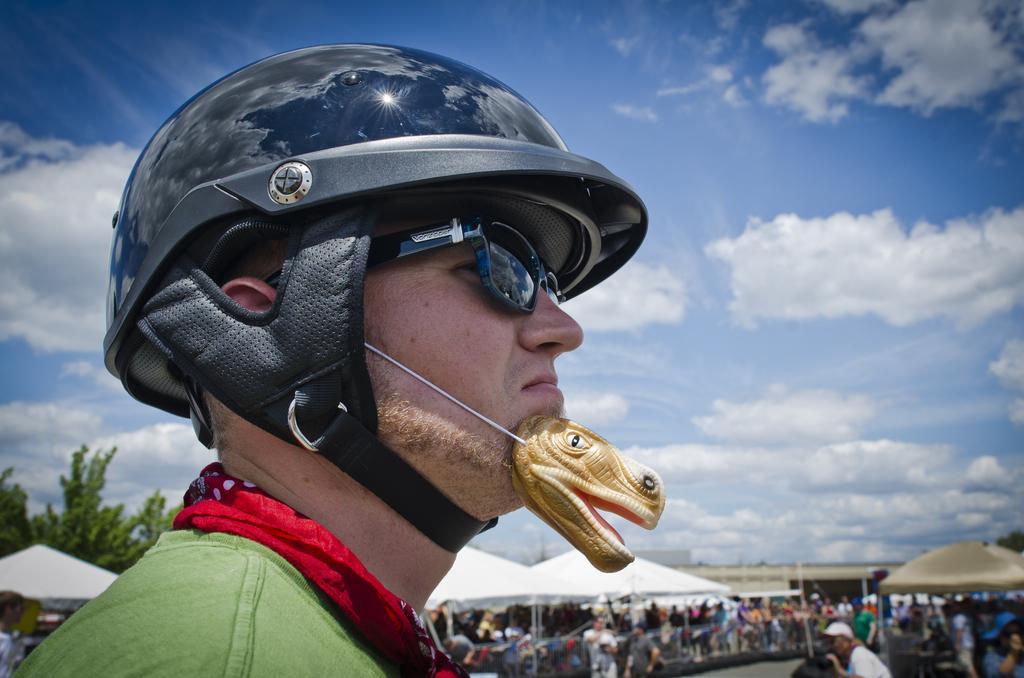In one or two sentences, can you explain what this image depicts? In front of the image there is a person wearing a helmet and a toy around his face, behind the person there are a few people standing in front of the tents. In the tents there are some objects. Behind the tents there are trees and buildings. At the top of the image there are clouds in the sky. 